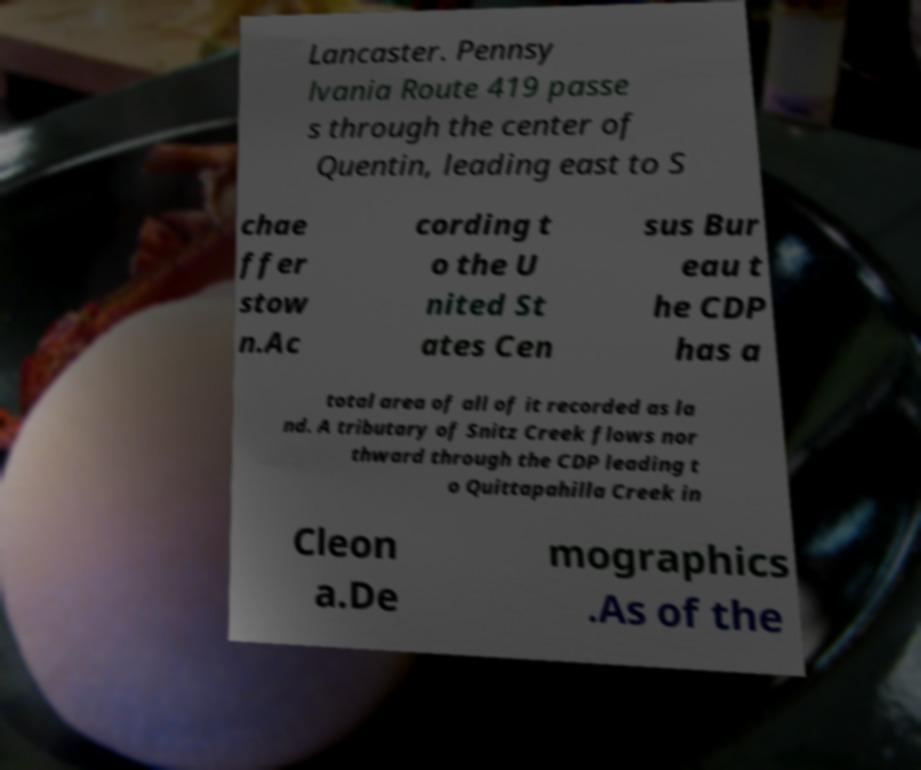Please identify and transcribe the text found in this image. Lancaster. Pennsy lvania Route 419 passe s through the center of Quentin, leading east to S chae ffer stow n.Ac cording t o the U nited St ates Cen sus Bur eau t he CDP has a total area of all of it recorded as la nd. A tributary of Snitz Creek flows nor thward through the CDP leading t o Quittapahilla Creek in Cleon a.De mographics .As of the 